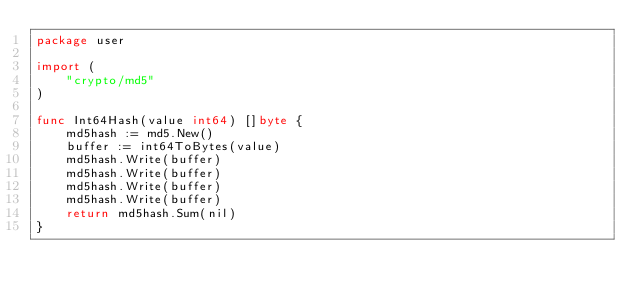<code> <loc_0><loc_0><loc_500><loc_500><_Go_>package user

import (
	"crypto/md5"
)

func Int64Hash(value int64) []byte {
	md5hash := md5.New()
	buffer := int64ToBytes(value)
	md5hash.Write(buffer)
	md5hash.Write(buffer)
	md5hash.Write(buffer)
	md5hash.Write(buffer)
	return md5hash.Sum(nil)
}
</code> 